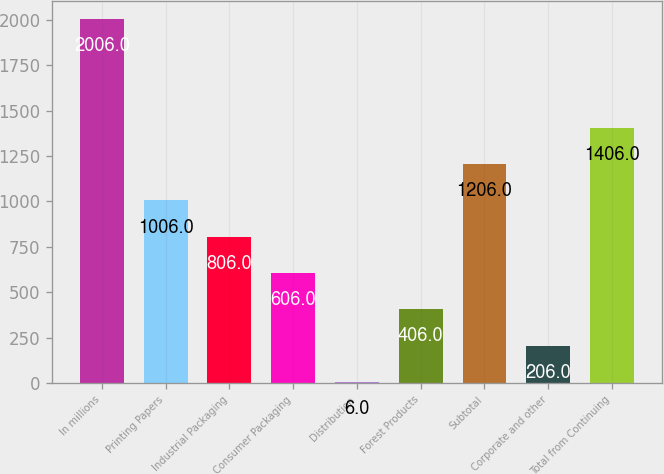Convert chart to OTSL. <chart><loc_0><loc_0><loc_500><loc_500><bar_chart><fcel>In millions<fcel>Printing Papers<fcel>Industrial Packaging<fcel>Consumer Packaging<fcel>Distribution<fcel>Forest Products<fcel>Subtotal<fcel>Corporate and other<fcel>Total from Continuing<nl><fcel>2006<fcel>1006<fcel>806<fcel>606<fcel>6<fcel>406<fcel>1206<fcel>206<fcel>1406<nl></chart> 